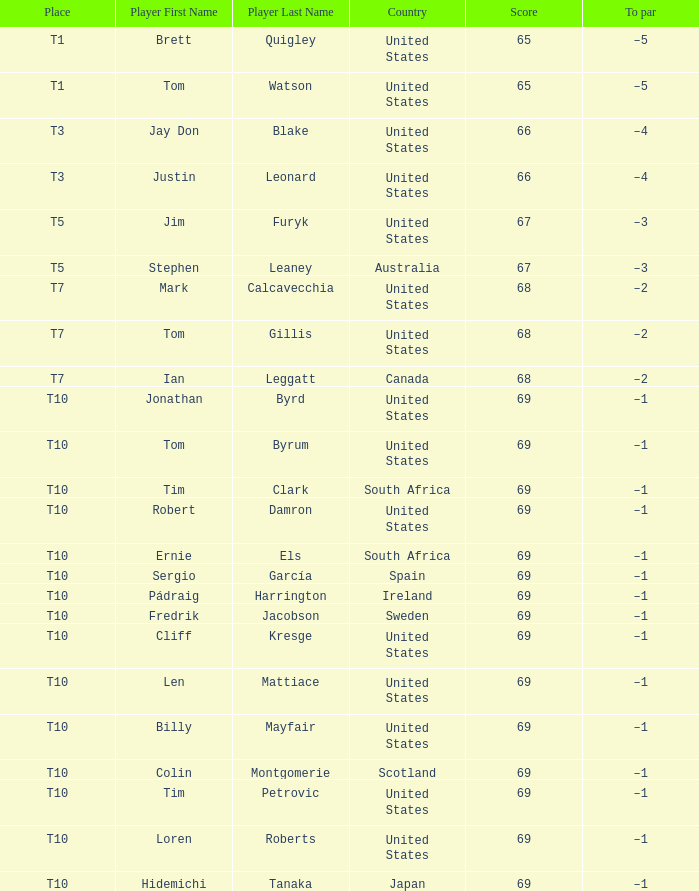Which country has is Len Mattiace in T10 place? United States. 